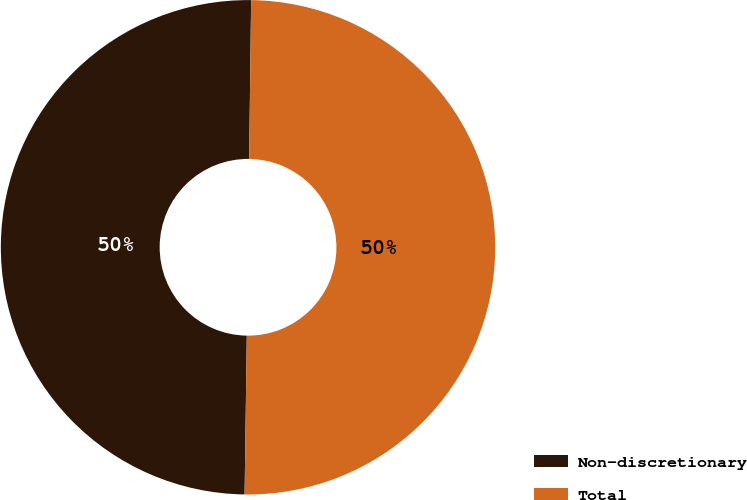Convert chart to OTSL. <chart><loc_0><loc_0><loc_500><loc_500><pie_chart><fcel>Non-discretionary<fcel>Total<nl><fcel>49.98%<fcel>50.02%<nl></chart> 